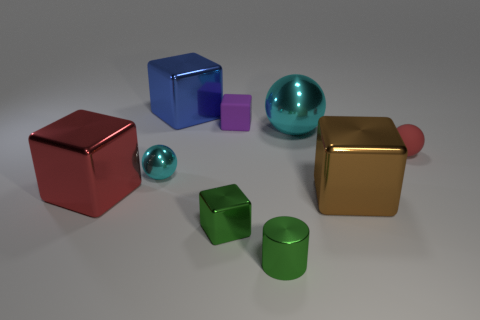How many brown cylinders have the same size as the rubber sphere?
Provide a succinct answer. 0. There is a small rubber object that is to the left of the tiny cylinder; what is its color?
Ensure brevity in your answer.  Purple. What number of other objects are the same size as the brown block?
Your response must be concise. 3. What is the size of the object that is to the right of the green metal cylinder and on the left side of the brown block?
Your response must be concise. Large. Does the small metallic cube have the same color as the object in front of the tiny green cube?
Make the answer very short. Yes. Are there any small cyan rubber objects of the same shape as the small red matte object?
Give a very brief answer. No. What number of objects are matte cubes or objects that are to the left of the big sphere?
Provide a succinct answer. 6. How many other things are the same material as the tiny purple object?
Offer a very short reply. 1. What number of things are either cyan things or tiny metallic objects?
Give a very brief answer. 4. Are there more cyan things behind the tiny green metallic cylinder than tiny shiny things that are to the right of the rubber block?
Give a very brief answer. Yes. 